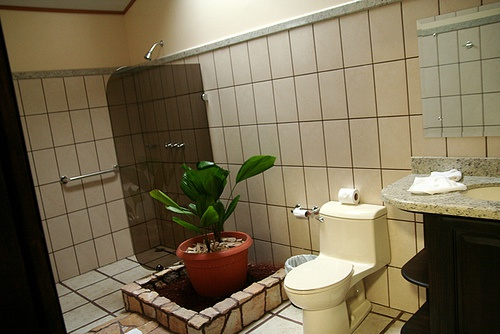Describe the objects in this image and their specific colors. I can see toilet in black, beige, and tan tones, potted plant in black, maroon, and darkgreen tones, and sink in black, tan, ivory, and beige tones in this image. 